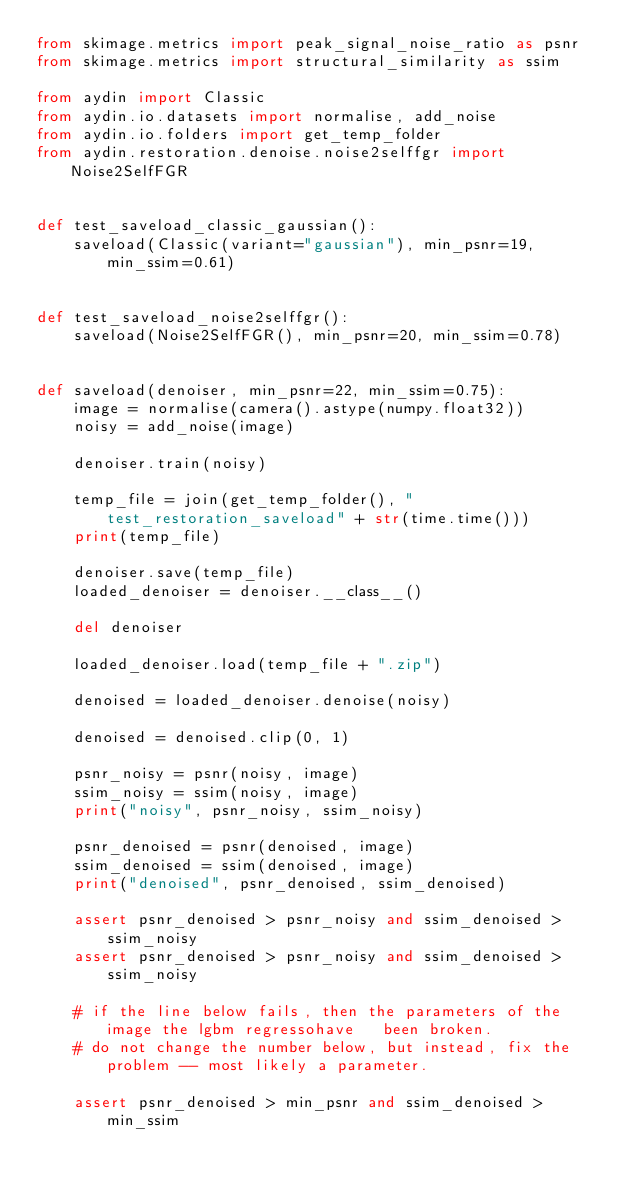<code> <loc_0><loc_0><loc_500><loc_500><_Python_>from skimage.metrics import peak_signal_noise_ratio as psnr
from skimage.metrics import structural_similarity as ssim

from aydin import Classic
from aydin.io.datasets import normalise, add_noise
from aydin.io.folders import get_temp_folder
from aydin.restoration.denoise.noise2selffgr import Noise2SelfFGR


def test_saveload_classic_gaussian():
    saveload(Classic(variant="gaussian"), min_psnr=19, min_ssim=0.61)


def test_saveload_noise2selffgr():
    saveload(Noise2SelfFGR(), min_psnr=20, min_ssim=0.78)


def saveload(denoiser, min_psnr=22, min_ssim=0.75):
    image = normalise(camera().astype(numpy.float32))
    noisy = add_noise(image)

    denoiser.train(noisy)

    temp_file = join(get_temp_folder(), "test_restoration_saveload" + str(time.time()))
    print(temp_file)

    denoiser.save(temp_file)
    loaded_denoiser = denoiser.__class__()

    del denoiser

    loaded_denoiser.load(temp_file + ".zip")

    denoised = loaded_denoiser.denoise(noisy)

    denoised = denoised.clip(0, 1)

    psnr_noisy = psnr(noisy, image)
    ssim_noisy = ssim(noisy, image)
    print("noisy", psnr_noisy, ssim_noisy)

    psnr_denoised = psnr(denoised, image)
    ssim_denoised = ssim(denoised, image)
    print("denoised", psnr_denoised, ssim_denoised)

    assert psnr_denoised > psnr_noisy and ssim_denoised > ssim_noisy
    assert psnr_denoised > psnr_noisy and ssim_denoised > ssim_noisy

    # if the line below fails, then the parameters of the image the lgbm regressohave   been broken.
    # do not change the number below, but instead, fix the problem -- most likely a parameter.

    assert psnr_denoised > min_psnr and ssim_denoised > min_ssim
</code> 